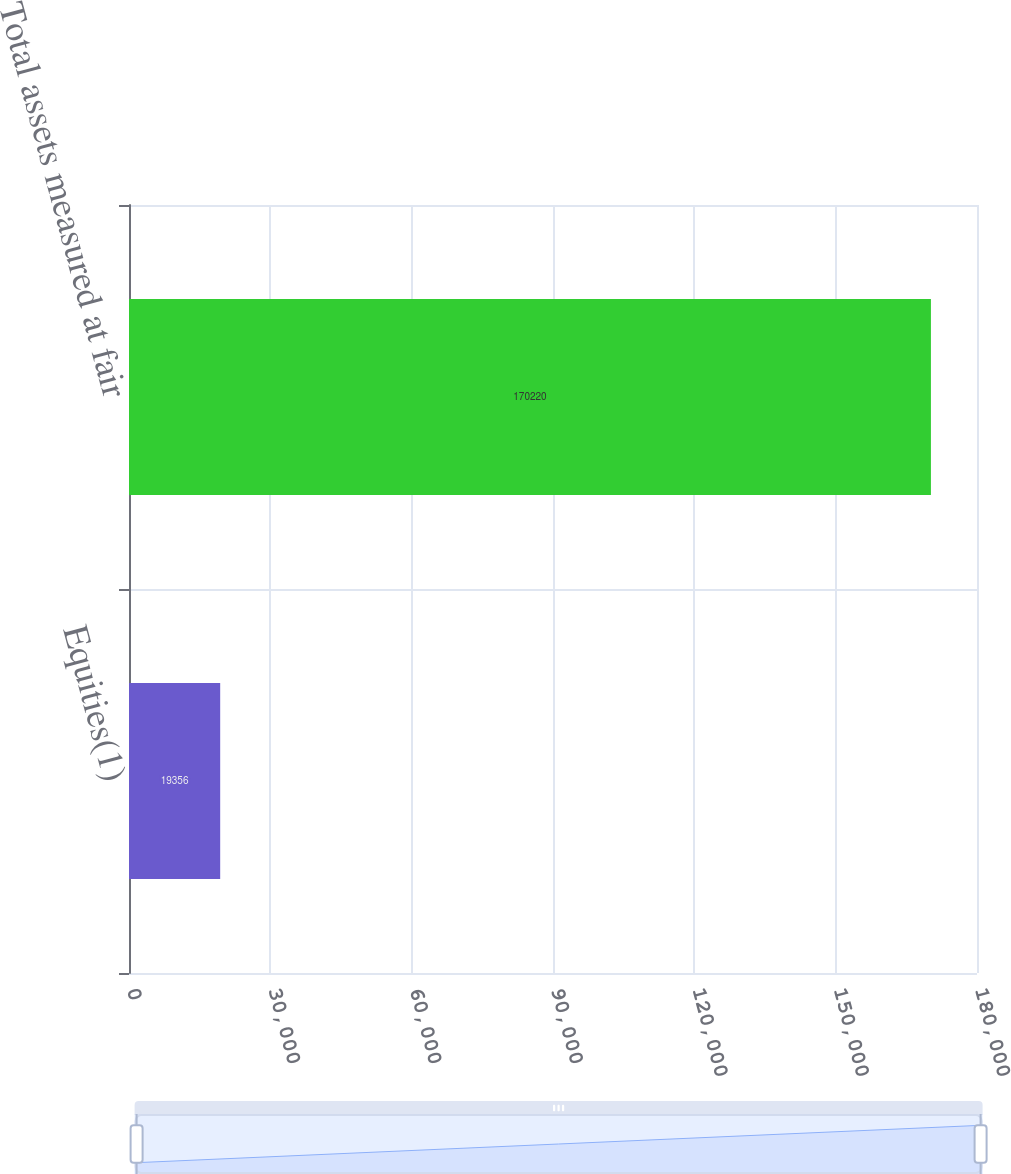Convert chart. <chart><loc_0><loc_0><loc_500><loc_500><bar_chart><fcel>Equities(1)<fcel>Total assets measured at fair<nl><fcel>19356<fcel>170220<nl></chart> 